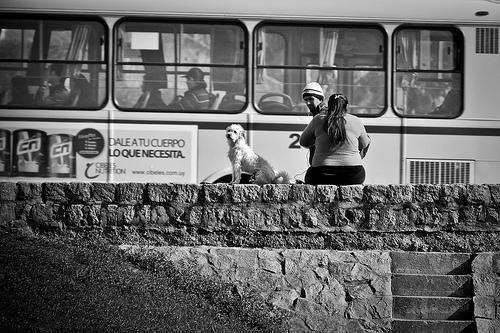How many people outside the bus?
Give a very brief answer. 2. How many dogs are shown?
Give a very brief answer. 1. How many people are sitting on the wall?
Give a very brief answer. 1. How many people are shown, not counting the ones on the bus?
Give a very brief answer. 2. How many people on the bus can be seen?
Give a very brief answer. 2. 